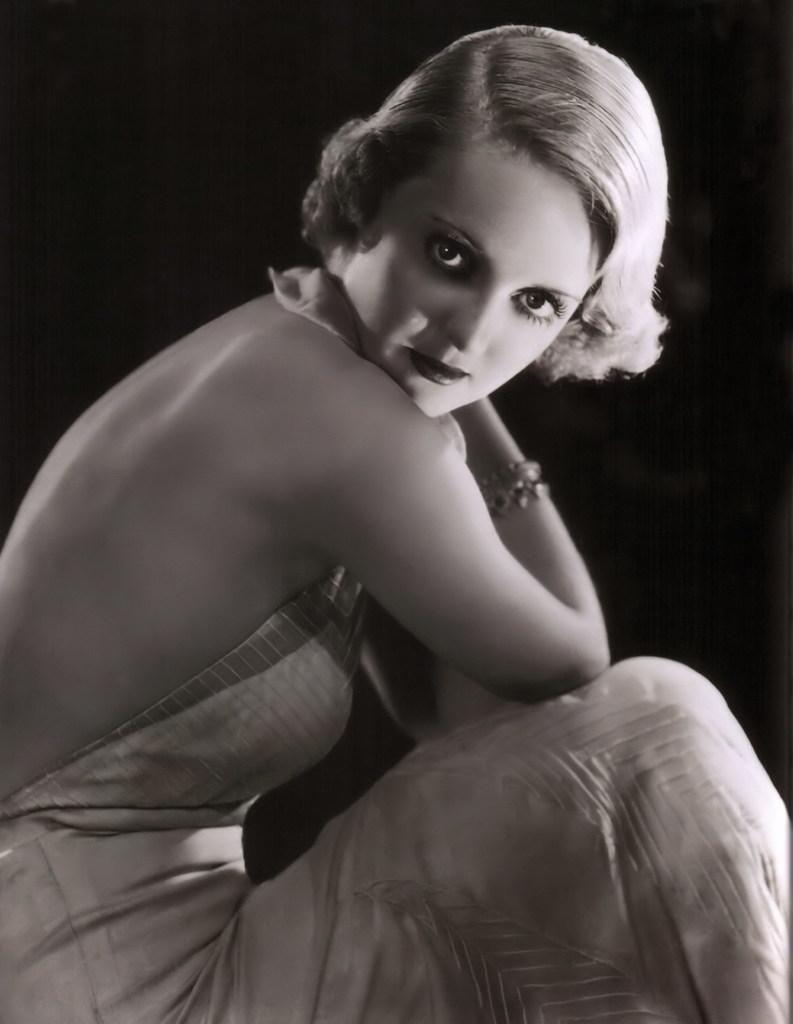What is the color scheme of the image? The image is black and white. Can you describe the main subject in the image? There is a woman in the image. What color is the background of the image? The background of the image is black. Can you tell me how many stalks of celery are in the woman's hand in the image? There is no celery present in the image, so it is not possible to determine the number of stalks in the woman's hand. 